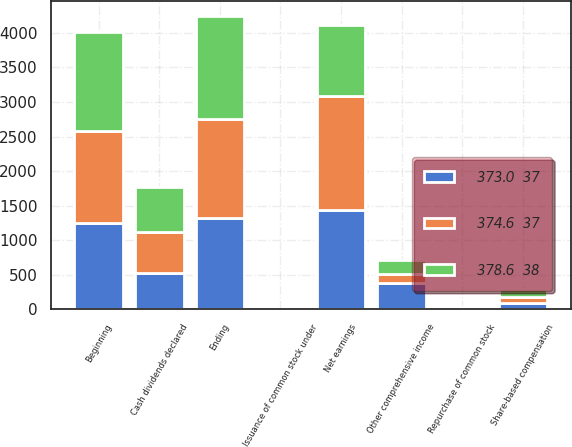<chart> <loc_0><loc_0><loc_500><loc_500><stacked_bar_chart><ecel><fcel>Issuance of common stock under<fcel>Beginning<fcel>Repurchase of common stock<fcel>Share-based compensation<fcel>Ending<fcel>Net earnings<fcel>Cash dividends declared<fcel>Other comprehensive income<nl><fcel>378.6  38<fcel>1.7<fcel>1432<fcel>7<fcel>113<fcel>1496<fcel>1020<fcel>653<fcel>208<nl><fcel>374.6  37<fcel>1.7<fcel>1321<fcel>1<fcel>97<fcel>1432<fcel>1647<fcel>585<fcel>122<nl><fcel>373.0  37<fcel>1.8<fcel>1252<fcel>25<fcel>86<fcel>1321<fcel>1439<fcel>532<fcel>385<nl></chart> 